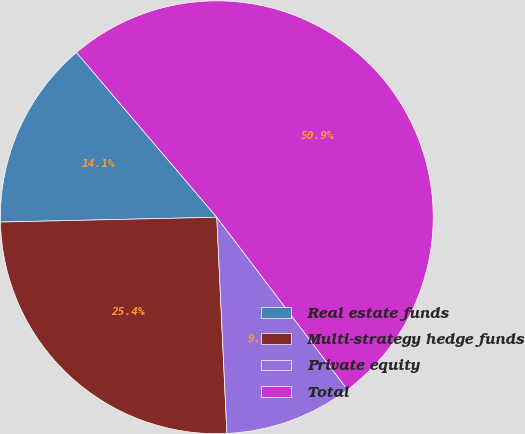Convert chart. <chart><loc_0><loc_0><loc_500><loc_500><pie_chart><fcel>Real estate funds<fcel>Multi-strategy hedge funds<fcel>Private equity<fcel>Total<nl><fcel>14.13%<fcel>25.39%<fcel>9.58%<fcel>50.9%<nl></chart> 